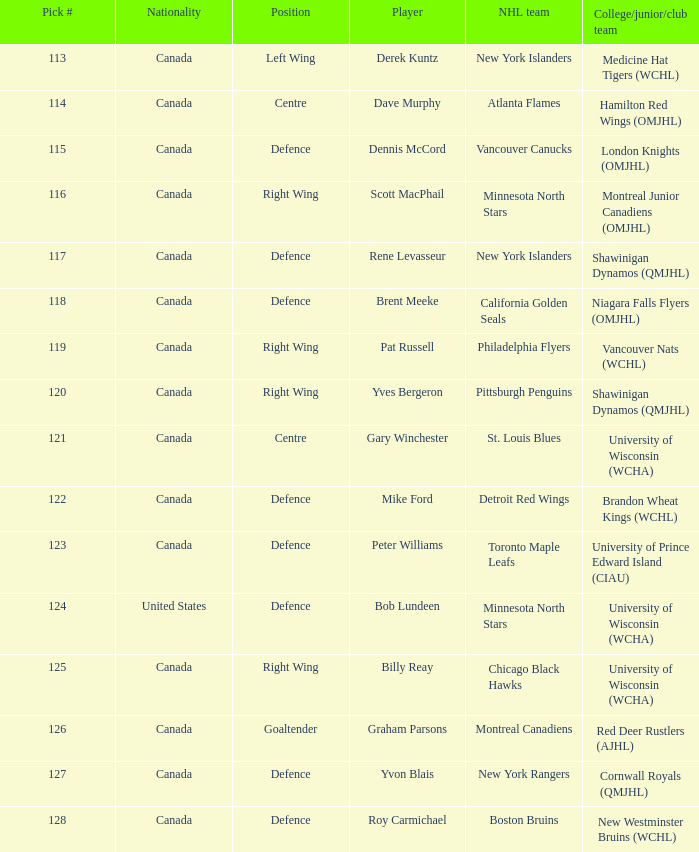Name the position for pick number 128 Defence. 